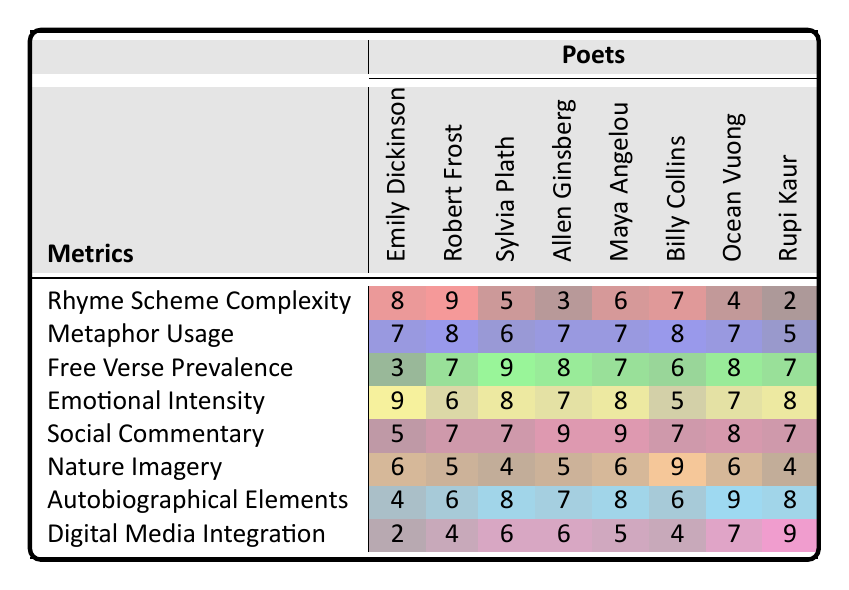What is the Rhyme Scheme Complexity of Allen Ginsberg? The table indicates that Allen Ginsberg has a Rhyme Scheme Complexity score of 3.
Answer: 3 Which poet has the highest Metaphor Usage? From the table, Robert Frost has the highest Metaphor Usage score of 8.
Answer: Robert Frost What is the lowest Free Verse Prevalence score? The lowest Free Verse Prevalence score in the table is 3, which belongs to Emily Dickinson.
Answer: 3 How many poets have a Social Commentary score of 9? The table shows that two poets, Allen Ginsberg and Maya Angelou, have a Social Commentary score of 9.
Answer: 2 What is the average Emotional Intensity score for the poets? To find the average, we sum the Emotional Intensity scores: (9 + 6 + 8 + 7 + 8 + 5 + 7 + 8) = 58. There are 8 poets, so the average is 58/8 = 7.25.
Answer: 7.25 Does Ocean Vuong have a higher Nature Imagery score than Sylvia Plath? Ocean Vuong's Nature Imagery score is 6, while Sylvia Plath's is 4. Therefore, Ocean Vuong does have a higher score.
Answer: Yes Which poet has the highest combined score in Autobiographical Elements and Digital Media Integration? The scores are: Ocean Vuong (9 + 7) = 16, Sylvia Plath (8 + 6) = 14, Billy Collins (6 + 4) = 10, Rupi Kaur (8 + 9) = 17. The highest combined score is for Rupi Kaur at 17.
Answer: Rupi Kaur What is the difference between the highest and lowest Rhyme Scheme Complexity scores? The highest score is 9 (Robert Frost) and the lowest is 2 (Rupi Kaur), so the difference is 9 - 2 = 7.
Answer: 7 Which poet is most associated with Digital Media Integration? Rupi Kaur has the highest score for Digital Media Integration at 9, making her the most associated poet in this metric.
Answer: Rupi Kaur Is there any poet who has an Emotional Intensity score of 5? Looking at the table, Billy Collins is the only poet with an Emotional Intensity score of 5.
Answer: Yes 